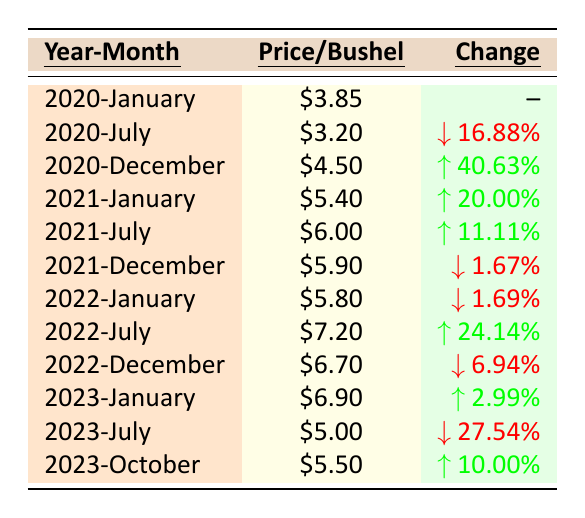What was the price of corn per bushel in January 2021? The table shows the price listed for January 2021 is $5.40.
Answer: $5.40 What is the price of corn per bushel in July 2022? Referring to the table, the price in July 2022 is $7.20.
Answer: $7.20 Did the price of corn increase from July 2020 to December 2020? In July 2020, the price was $3.20, and in December 2020, it was $4.50, which indicates an increase.
Answer: Yes What was the percentage change in corn price from January 2023 to July 2023? The price in January 2023 was $6.90 and dropped to $5.00 in July 2023. The percentage change is calculated as (($5.00 - $6.90) / $6.90) * 100 = -27.54%.
Answer: -27.54% What is the average price of corn per bushel in the year 2022? The prices for 2022 are $5.80 (January), $7.20 (July), and $6.70 (December). The average is calculated as (5.80 + 7.20 + 6.70) / 3 = 6.23.
Answer: $6.23 What was the highest price of corn per bushel recorded in the table? The highest price listed is $7.20 in July 2022.
Answer: $7.20 Was there a decrease in corn price from December 2021 to January 2022? The price in December 2021 was $5.90 and in January 2022 it was $5.80, indicating a decrease.
Answer: Yes Calculate the total price change from July 2021 to October 2023. The price in July 2021 was $6.00 and in October 2023 it is $5.50. The change is ($5.50 - $6.00) = -$0.50.
Answer: -$0.50 Which month in 2023 had the lowest price for corn per bushel? In 2023, the lowest price recorded was in July at $5.00.
Answer: July How many times did the price of corn per bushel increase from one year to another in the given data? The price increased from 2020 to 2021 (from $3.85 to $5.40) and from 2021 to 2022 (from $5.90 to $7.20). Therefore, it increased twice.
Answer: 2 times 